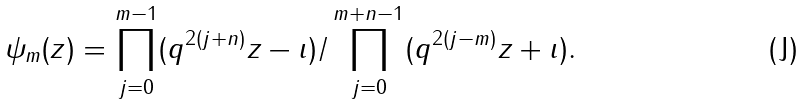<formula> <loc_0><loc_0><loc_500><loc_500>\psi _ { m } ( z ) = \prod ^ { m - 1 } _ { j = 0 } ( q ^ { 2 ( j + n ) } z - \imath ) / \prod ^ { m + n - 1 } _ { j = 0 } ( q ^ { 2 ( j - m ) } z + \imath ) .</formula> 